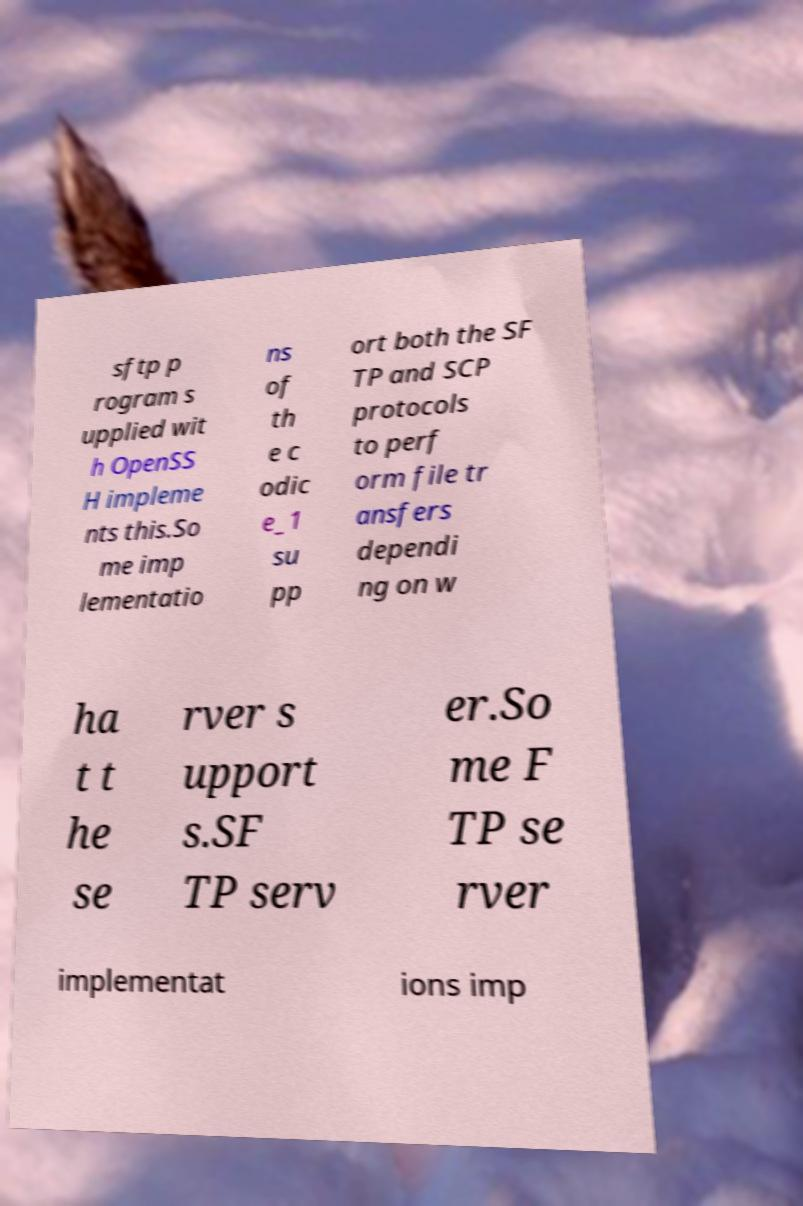Please read and relay the text visible in this image. What does it say? sftp p rogram s upplied wit h OpenSS H impleme nts this.So me imp lementatio ns of th e c odic e_1 su pp ort both the SF TP and SCP protocols to perf orm file tr ansfers dependi ng on w ha t t he se rver s upport s.SF TP serv er.So me F TP se rver implementat ions imp 